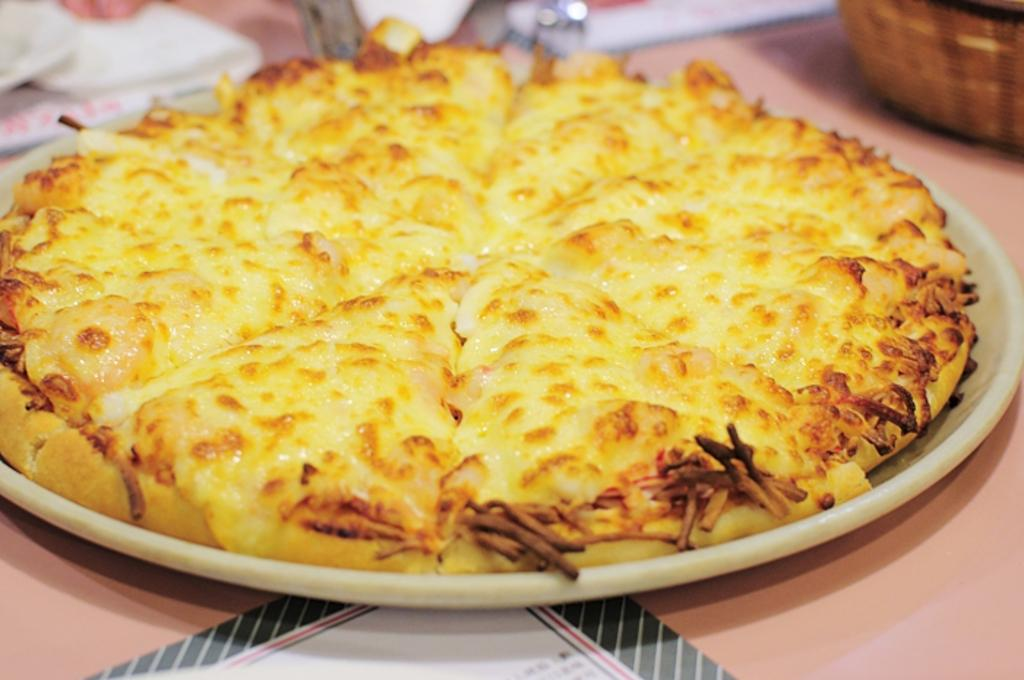What is on the plate that is visible in the image? There is food on a plate in the image. What can be seen in the background of the image? There are objects visible at the back of the image. What type of container is present in the image? There is a basket in the image. What is on the table in the image? There is a paper on the table in the image. What belief does the actor express in the image? There is no actor present in the image, and therefore no belief can be attributed to them. 